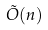<formula> <loc_0><loc_0><loc_500><loc_500>\tilde { O } ( n )</formula> 